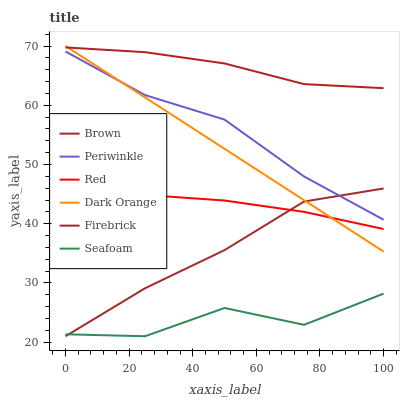Does Seafoam have the minimum area under the curve?
Answer yes or no. Yes. Does Firebrick have the maximum area under the curve?
Answer yes or no. Yes. Does Dark Orange have the minimum area under the curve?
Answer yes or no. No. Does Dark Orange have the maximum area under the curve?
Answer yes or no. No. Is Dark Orange the smoothest?
Answer yes or no. Yes. Is Seafoam the roughest?
Answer yes or no. Yes. Is Firebrick the smoothest?
Answer yes or no. No. Is Firebrick the roughest?
Answer yes or no. No. Does Brown have the lowest value?
Answer yes or no. Yes. Does Dark Orange have the lowest value?
Answer yes or no. No. Does Dark Orange have the highest value?
Answer yes or no. Yes. Does Firebrick have the highest value?
Answer yes or no. No. Is Seafoam less than Dark Orange?
Answer yes or no. Yes. Is Firebrick greater than Red?
Answer yes or no. Yes. Does Dark Orange intersect Brown?
Answer yes or no. Yes. Is Dark Orange less than Brown?
Answer yes or no. No. Is Dark Orange greater than Brown?
Answer yes or no. No. Does Seafoam intersect Dark Orange?
Answer yes or no. No. 